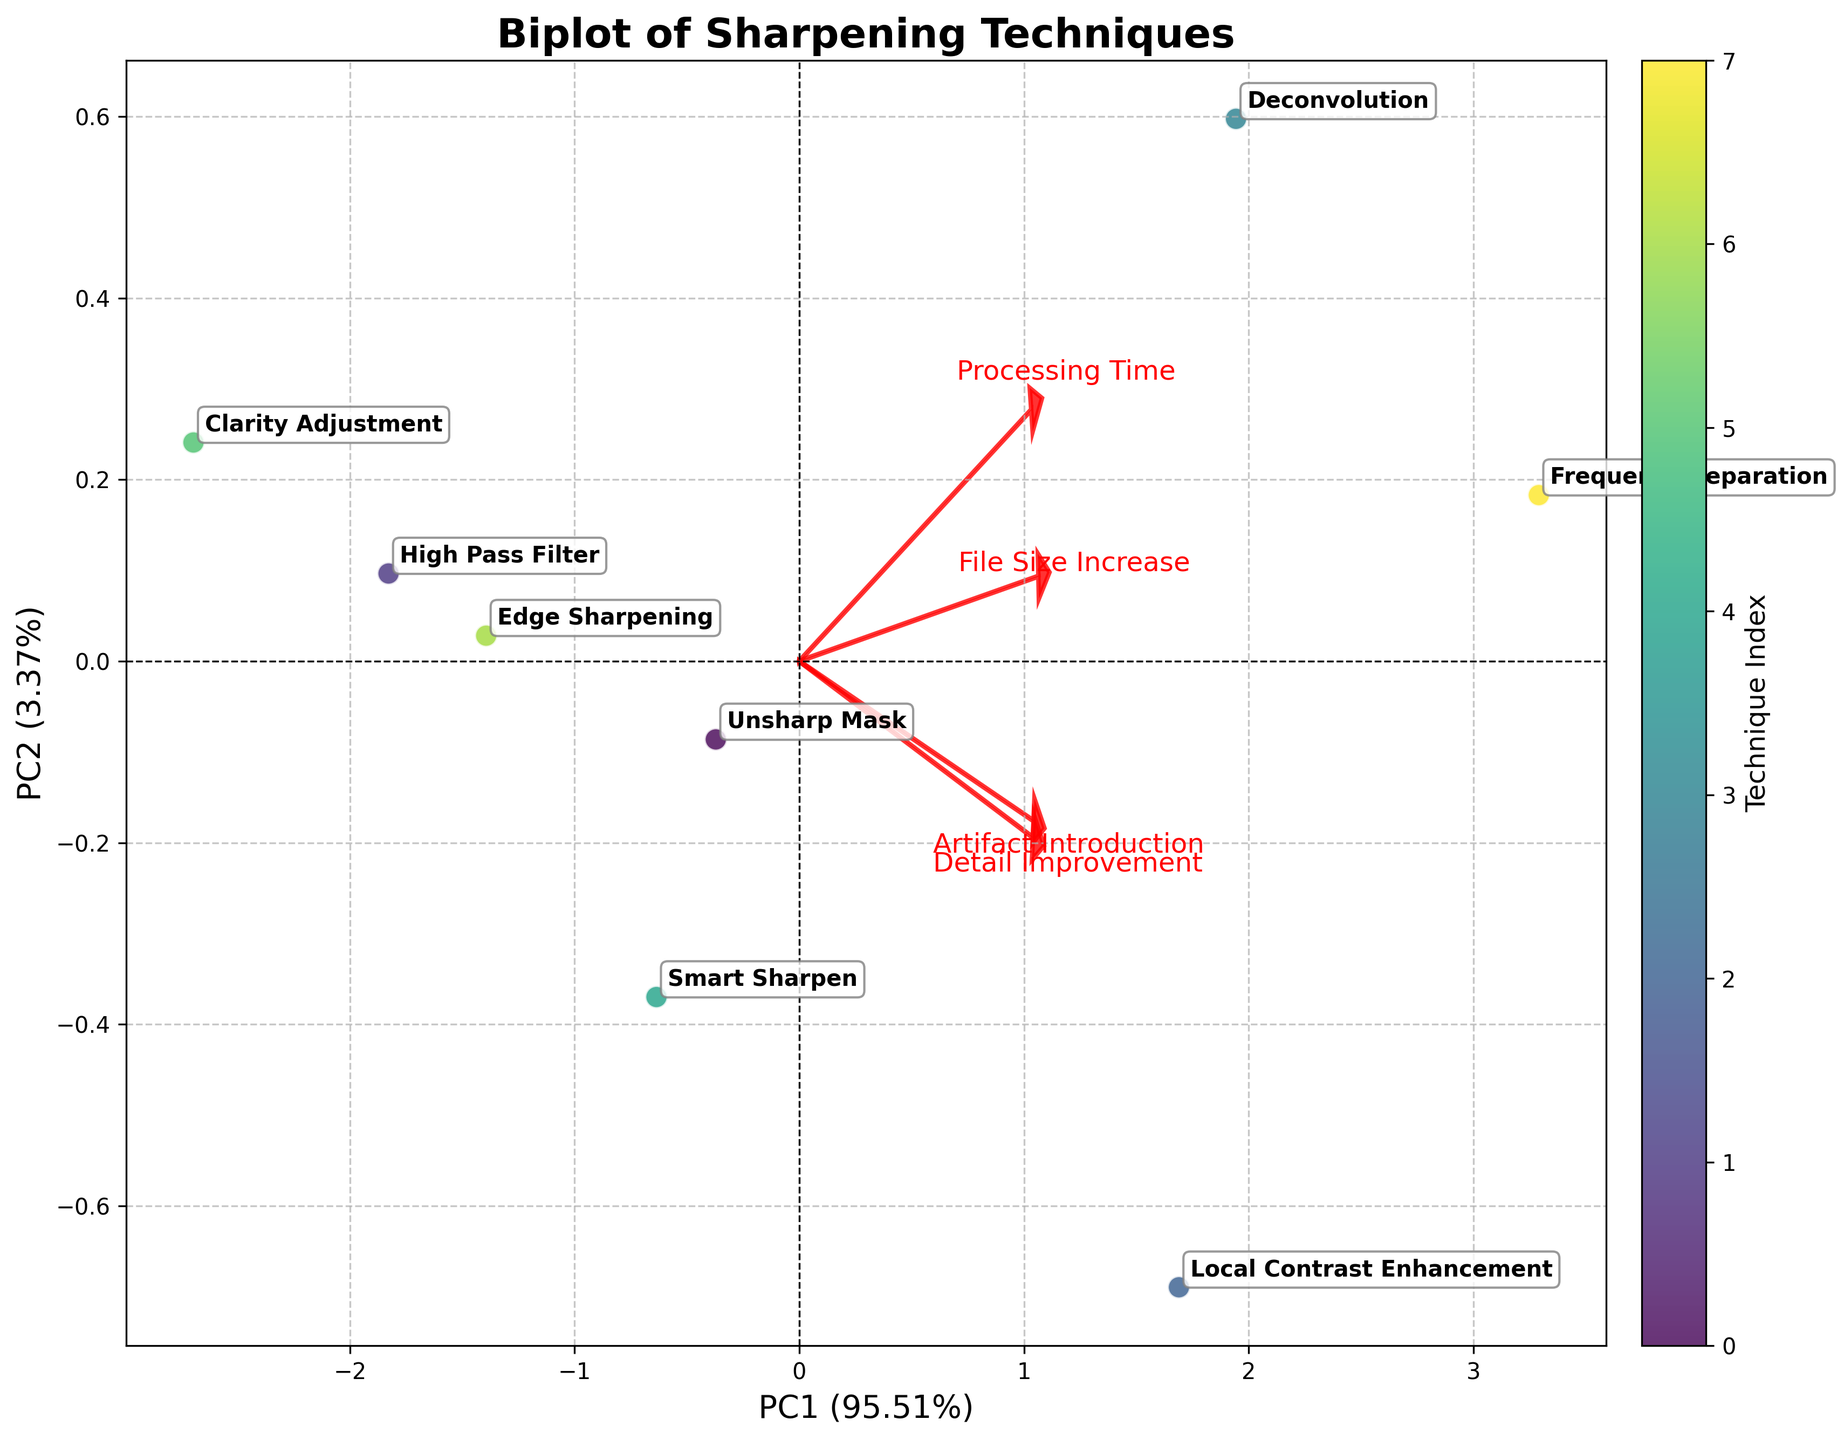How many techniques are displayed in the biplot? The biplot plot shows the data points for each technique. By counting the annotations, we can determine the number of techniques.
Answer: 8 Which technique shows the highest value for Detail Improvement? By examining the annotations and their positions relative to the loading vector labeled "Detail Improvement," the technique furthest along this direction will have the highest detail improvement value.
Answer: Frequency Separation Which feature has the highest loading on the second principal component (PC2)? The loading vectors provide visual indications of the feature contributions. The feature with the longest arrow aligned closely with the PC2 axis has the highest loading on PC2.
Answer: Processing Time Is there a technique that's closer to the origin compared to others? If so, which one? Examine the scatter plot to see which point is closest to the origin (0,0). This technique shows the least variance in features.
Answer: Clarity Adjustment Which two techniques appear closest to each other on the biplot? Compare the distances between data points on the scatter plot. The two techniques with the least distance between them are the closest to each other.
Answer: High Pass Filter and Edge Sharpening What do the loading vectors indicate about the relationship between Detail Improvement and Artifact Introduction? The directions and lengths of the loading vectors give insights into how these features relate. Vectors pointing in similar directions suggest positive correlation, while opposing directions suggest negative.
Answer: Positively correlated Which feature appears to contribute most to the first principal component (PC1)? The feature with the loading vector that has the longest projection on the PC1 axis is the one that contributes most to PC1.
Answer: Detail Improvement Which feature is least aligned with the direction of Frequency Separation in the biplot? Identify the position of Frequency Separation and check which loading vector is least aligned with its direction.
Answer: Clarity Adjustment 